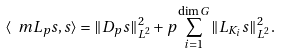<formula> <loc_0><loc_0><loc_500><loc_500>\langle \ m L _ { p } s , s \rangle = \| D _ { p } s \| ^ { 2 } _ { L ^ { 2 } } + p \sum _ { i = 1 } ^ { \dim G } \| L _ { K _ { i } } s \| ^ { 2 } _ { L ^ { 2 } } .</formula> 